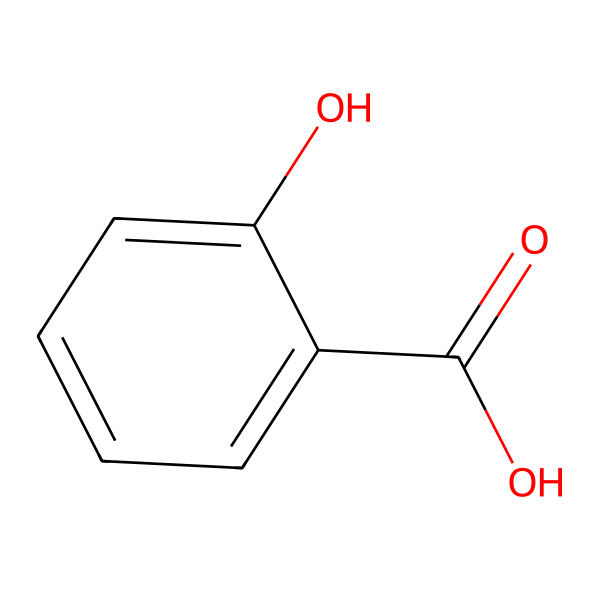What is the name of this chemical? The SMILES representation corresponds to the structure of salicylic acid, which is known for its use in skincare.
Answer: salicylic acid How many carbon atoms are present in the structure? By analyzing the chemical structure, we can count a total of seven carbon atoms in the benzene ring and the carboxylic acid group.
Answer: seven What functional group is represented by the -COOH part of the molecule? The -COOH represents a carboxylic acid functional group, which is characteristic of acids and relates to the acidity of salicylic acid.
Answer: carboxylic acid What is the primary skincare benefit associated with salicylic acid? Salicylic acid is primarily used for its ability to exfoliate the skin and unclog pores, making it beneficial for treating acne.
Answer: acne treatment How does the hydroxyl group (-OH) influence the properties of salicylic acid? The hydroxyl group (-OH) contributes to the polar nature of salicylic acid, enhancing its solubility in water and providing antioxidant properties.
Answer: increases solubility Which bond type predominates in the carbon ring structure of salicylic acid? The carbon ring structure contains mostly single bonds along with alternating double bonds that illustrate resonance, common in aromatic compounds.
Answer: aromatic bonds What effect does salicylic acid have on skin stress relief? Salicylic acid can help reduce inflammation and irritation in the skin, thus alleviating stress-related skin issues like redness and swelling.
Answer: reduces inflammation 